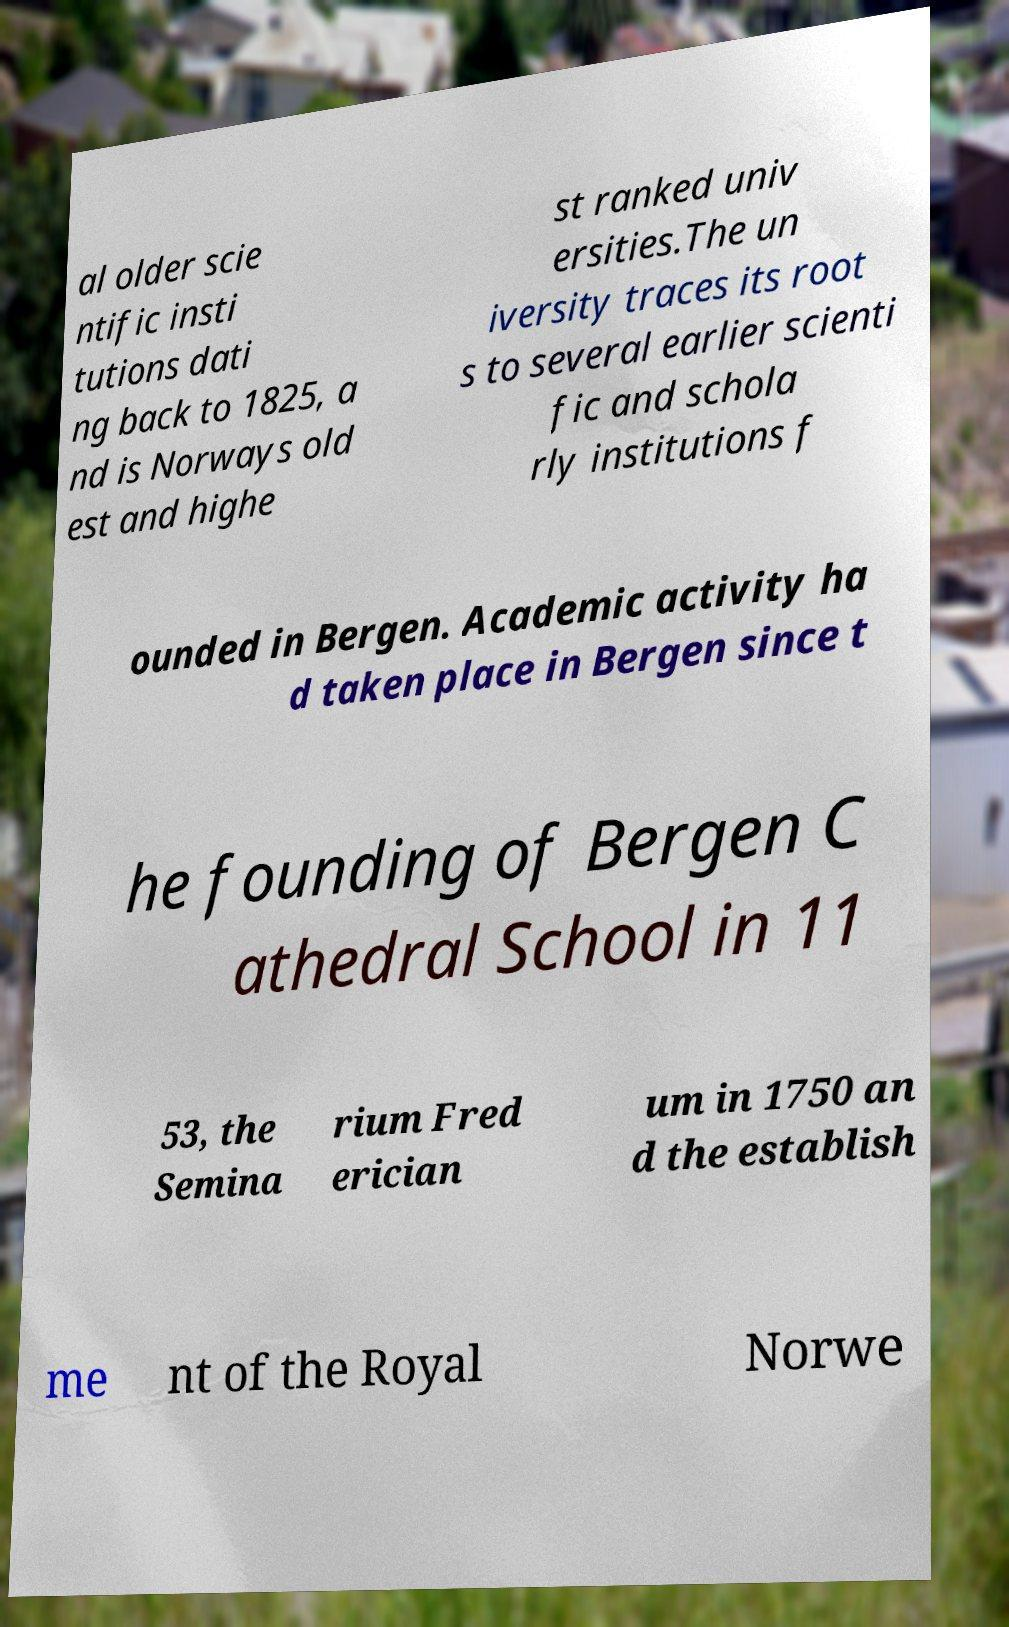Please identify and transcribe the text found in this image. al older scie ntific insti tutions dati ng back to 1825, a nd is Norways old est and highe st ranked univ ersities.The un iversity traces its root s to several earlier scienti fic and schola rly institutions f ounded in Bergen. Academic activity ha d taken place in Bergen since t he founding of Bergen C athedral School in 11 53, the Semina rium Fred erician um in 1750 an d the establish me nt of the Royal Norwe 